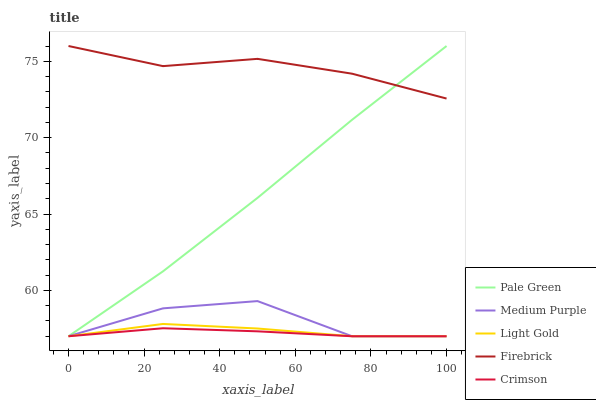Does Crimson have the minimum area under the curve?
Answer yes or no. Yes. Does Firebrick have the minimum area under the curve?
Answer yes or no. No. Does Crimson have the maximum area under the curve?
Answer yes or no. No. Is Pale Green the smoothest?
Answer yes or no. Yes. Is Medium Purple the roughest?
Answer yes or no. Yes. Is Crimson the smoothest?
Answer yes or no. No. Is Crimson the roughest?
Answer yes or no. No. Does Firebrick have the lowest value?
Answer yes or no. No. Does Crimson have the highest value?
Answer yes or no. No. Is Crimson less than Firebrick?
Answer yes or no. Yes. Is Firebrick greater than Medium Purple?
Answer yes or no. Yes. Does Crimson intersect Firebrick?
Answer yes or no. No. 